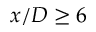Convert formula to latex. <formula><loc_0><loc_0><loc_500><loc_500>x / D \geq 6</formula> 